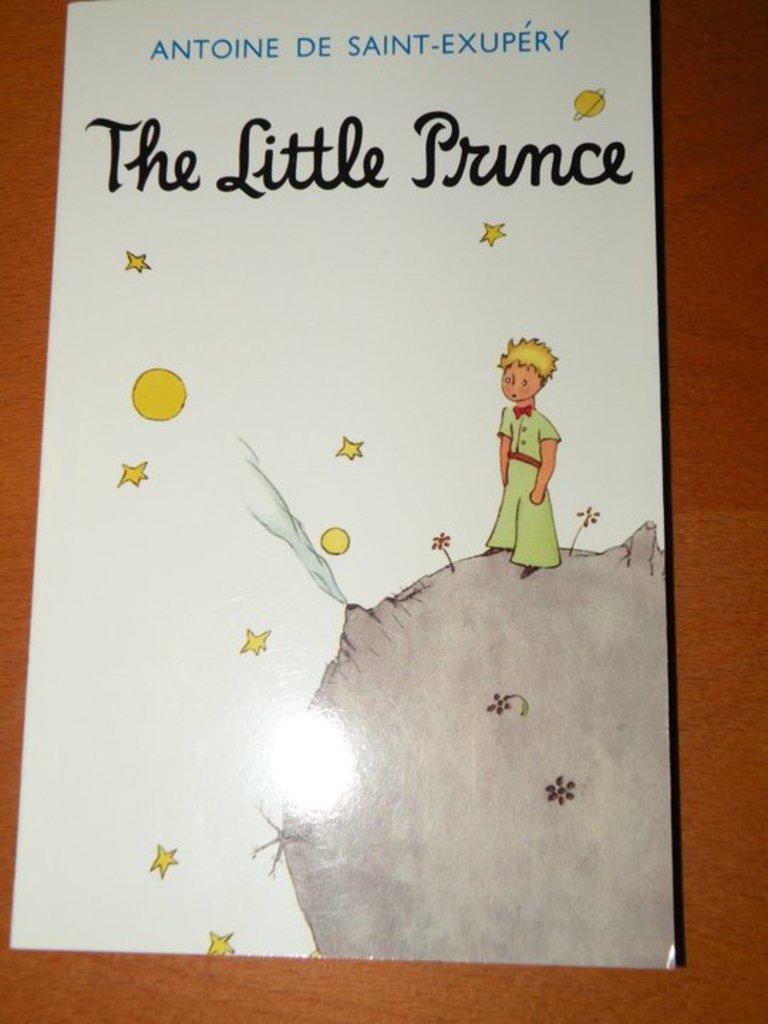What is the authors name on the book?
Provide a short and direct response. Antoine de saint-exupery. What is the title of the book?
Make the answer very short. The little prince. 